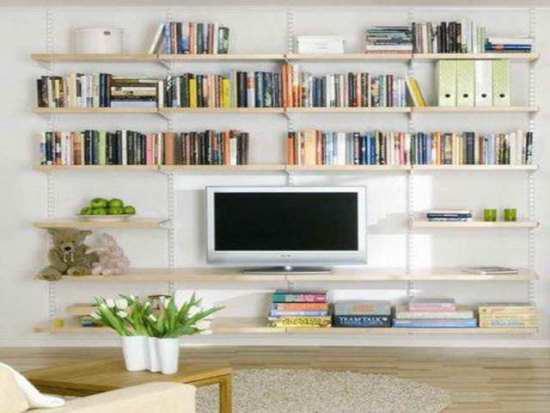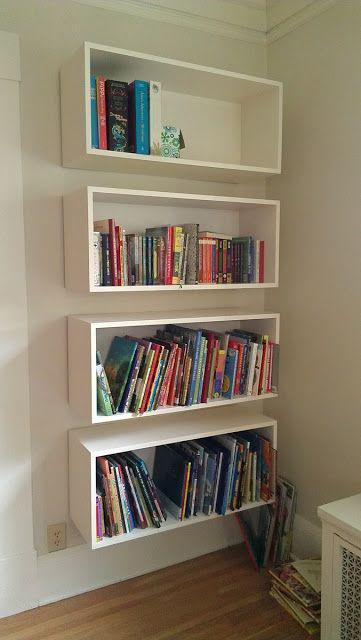The first image is the image on the left, the second image is the image on the right. Considering the images on both sides, is "In one image, a rectangular shelf unit has been created by attaching individual wooden boxes to a wall, leaving open space between them where the wall is visible." valid? Answer yes or no. Yes. The first image is the image on the left, the second image is the image on the right. Analyze the images presented: Is the assertion "Books are hanging in traditional rectangular boxes on the wall in the image on the right." valid? Answer yes or no. Yes. 